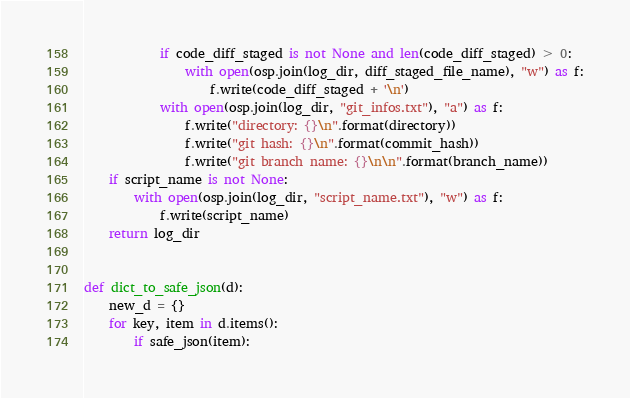<code> <loc_0><loc_0><loc_500><loc_500><_Python_>            if code_diff_staged is not None and len(code_diff_staged) > 0:
                with open(osp.join(log_dir, diff_staged_file_name), "w") as f:
                    f.write(code_diff_staged + '\n')
            with open(osp.join(log_dir, "git_infos.txt"), "a") as f:
                f.write("directory: {}\n".format(directory))
                f.write("git hash: {}\n".format(commit_hash))
                f.write("git branch name: {}\n\n".format(branch_name))
    if script_name is not None:
        with open(osp.join(log_dir, "script_name.txt"), "w") as f:
            f.write(script_name)
    return log_dir


def dict_to_safe_json(d):
    new_d = {}
    for key, item in d.items():
        if safe_json(item):</code> 